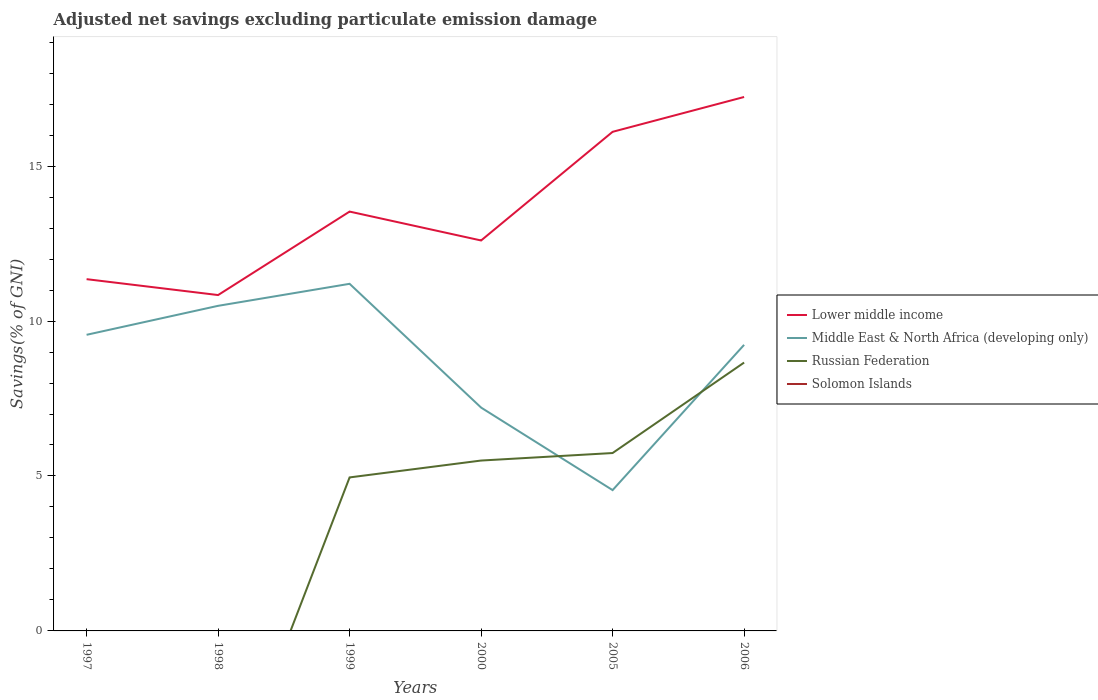Does the line corresponding to Russian Federation intersect with the line corresponding to Middle East & North Africa (developing only)?
Your answer should be compact. Yes. Is the number of lines equal to the number of legend labels?
Your answer should be compact. No. Across all years, what is the maximum adjusted net savings in Russian Federation?
Your response must be concise. 0. What is the total adjusted net savings in Lower middle income in the graph?
Your answer should be very brief. -3.51. What is the difference between the highest and the second highest adjusted net savings in Russian Federation?
Your answer should be compact. 8.66. What is the difference between the highest and the lowest adjusted net savings in Russian Federation?
Make the answer very short. 4. How many years are there in the graph?
Provide a succinct answer. 6. Does the graph contain any zero values?
Give a very brief answer. Yes. Where does the legend appear in the graph?
Give a very brief answer. Center right. How many legend labels are there?
Your answer should be compact. 4. What is the title of the graph?
Make the answer very short. Adjusted net savings excluding particulate emission damage. What is the label or title of the Y-axis?
Your response must be concise. Savings(% of GNI). What is the Savings(% of GNI) of Lower middle income in 1997?
Offer a terse response. 11.35. What is the Savings(% of GNI) in Middle East & North Africa (developing only) in 1997?
Provide a succinct answer. 9.56. What is the Savings(% of GNI) of Russian Federation in 1997?
Keep it short and to the point. 0. What is the Savings(% of GNI) of Solomon Islands in 1997?
Keep it short and to the point. 0. What is the Savings(% of GNI) of Lower middle income in 1998?
Your answer should be compact. 10.84. What is the Savings(% of GNI) of Middle East & North Africa (developing only) in 1998?
Make the answer very short. 10.49. What is the Savings(% of GNI) of Russian Federation in 1998?
Offer a very short reply. 0. What is the Savings(% of GNI) in Solomon Islands in 1998?
Give a very brief answer. 0. What is the Savings(% of GNI) of Lower middle income in 1999?
Your answer should be compact. 13.53. What is the Savings(% of GNI) of Middle East & North Africa (developing only) in 1999?
Offer a terse response. 11.2. What is the Savings(% of GNI) of Russian Federation in 1999?
Your answer should be very brief. 4.95. What is the Savings(% of GNI) in Solomon Islands in 1999?
Provide a short and direct response. 0. What is the Savings(% of GNI) of Lower middle income in 2000?
Provide a short and direct response. 12.6. What is the Savings(% of GNI) in Middle East & North Africa (developing only) in 2000?
Offer a terse response. 7.21. What is the Savings(% of GNI) of Russian Federation in 2000?
Offer a very short reply. 5.5. What is the Savings(% of GNI) of Solomon Islands in 2000?
Your answer should be compact. 0. What is the Savings(% of GNI) of Lower middle income in 2005?
Your answer should be compact. 16.11. What is the Savings(% of GNI) in Middle East & North Africa (developing only) in 2005?
Offer a terse response. 4.54. What is the Savings(% of GNI) of Russian Federation in 2005?
Give a very brief answer. 5.74. What is the Savings(% of GNI) of Solomon Islands in 2005?
Provide a short and direct response. 0. What is the Savings(% of GNI) in Lower middle income in 2006?
Ensure brevity in your answer.  17.23. What is the Savings(% of GNI) in Middle East & North Africa (developing only) in 2006?
Offer a very short reply. 9.23. What is the Savings(% of GNI) in Russian Federation in 2006?
Make the answer very short. 8.66. What is the Savings(% of GNI) in Solomon Islands in 2006?
Your answer should be compact. 0. Across all years, what is the maximum Savings(% of GNI) in Lower middle income?
Offer a very short reply. 17.23. Across all years, what is the maximum Savings(% of GNI) of Middle East & North Africa (developing only)?
Provide a succinct answer. 11.2. Across all years, what is the maximum Savings(% of GNI) of Russian Federation?
Provide a succinct answer. 8.66. Across all years, what is the minimum Savings(% of GNI) of Lower middle income?
Offer a very short reply. 10.84. Across all years, what is the minimum Savings(% of GNI) of Middle East & North Africa (developing only)?
Your response must be concise. 4.54. Across all years, what is the minimum Savings(% of GNI) in Russian Federation?
Provide a succinct answer. 0. What is the total Savings(% of GNI) in Lower middle income in the graph?
Your response must be concise. 81.66. What is the total Savings(% of GNI) of Middle East & North Africa (developing only) in the graph?
Ensure brevity in your answer.  52.23. What is the total Savings(% of GNI) in Russian Federation in the graph?
Offer a terse response. 24.85. What is the difference between the Savings(% of GNI) of Lower middle income in 1997 and that in 1998?
Your answer should be very brief. 0.51. What is the difference between the Savings(% of GNI) in Middle East & North Africa (developing only) in 1997 and that in 1998?
Make the answer very short. -0.93. What is the difference between the Savings(% of GNI) of Lower middle income in 1997 and that in 1999?
Your answer should be compact. -2.18. What is the difference between the Savings(% of GNI) of Middle East & North Africa (developing only) in 1997 and that in 1999?
Your response must be concise. -1.65. What is the difference between the Savings(% of GNI) of Lower middle income in 1997 and that in 2000?
Ensure brevity in your answer.  -1.25. What is the difference between the Savings(% of GNI) of Middle East & North Africa (developing only) in 1997 and that in 2000?
Provide a short and direct response. 2.35. What is the difference between the Savings(% of GNI) in Lower middle income in 1997 and that in 2005?
Give a very brief answer. -4.75. What is the difference between the Savings(% of GNI) of Middle East & North Africa (developing only) in 1997 and that in 2005?
Offer a terse response. 5.01. What is the difference between the Savings(% of GNI) of Lower middle income in 1997 and that in 2006?
Keep it short and to the point. -5.88. What is the difference between the Savings(% of GNI) in Middle East & North Africa (developing only) in 1997 and that in 2006?
Keep it short and to the point. 0.32. What is the difference between the Savings(% of GNI) in Lower middle income in 1998 and that in 1999?
Ensure brevity in your answer.  -2.69. What is the difference between the Savings(% of GNI) in Middle East & North Africa (developing only) in 1998 and that in 1999?
Offer a very short reply. -0.71. What is the difference between the Savings(% of GNI) in Lower middle income in 1998 and that in 2000?
Keep it short and to the point. -1.76. What is the difference between the Savings(% of GNI) of Middle East & North Africa (developing only) in 1998 and that in 2000?
Give a very brief answer. 3.28. What is the difference between the Savings(% of GNI) of Lower middle income in 1998 and that in 2005?
Your answer should be compact. -5.27. What is the difference between the Savings(% of GNI) of Middle East & North Africa (developing only) in 1998 and that in 2005?
Provide a short and direct response. 5.95. What is the difference between the Savings(% of GNI) of Lower middle income in 1998 and that in 2006?
Ensure brevity in your answer.  -6.39. What is the difference between the Savings(% of GNI) of Middle East & North Africa (developing only) in 1998 and that in 2006?
Make the answer very short. 1.26. What is the difference between the Savings(% of GNI) of Lower middle income in 1999 and that in 2000?
Your answer should be compact. 0.93. What is the difference between the Savings(% of GNI) of Middle East & North Africa (developing only) in 1999 and that in 2000?
Give a very brief answer. 3.99. What is the difference between the Savings(% of GNI) in Russian Federation in 1999 and that in 2000?
Your answer should be compact. -0.54. What is the difference between the Savings(% of GNI) in Lower middle income in 1999 and that in 2005?
Offer a terse response. -2.57. What is the difference between the Savings(% of GNI) in Middle East & North Africa (developing only) in 1999 and that in 2005?
Your response must be concise. 6.66. What is the difference between the Savings(% of GNI) in Russian Federation in 1999 and that in 2005?
Offer a terse response. -0.79. What is the difference between the Savings(% of GNI) in Lower middle income in 1999 and that in 2006?
Your answer should be very brief. -3.7. What is the difference between the Savings(% of GNI) of Middle East & North Africa (developing only) in 1999 and that in 2006?
Your answer should be compact. 1.97. What is the difference between the Savings(% of GNI) in Russian Federation in 1999 and that in 2006?
Provide a short and direct response. -3.71. What is the difference between the Savings(% of GNI) of Lower middle income in 2000 and that in 2005?
Your answer should be very brief. -3.51. What is the difference between the Savings(% of GNI) in Middle East & North Africa (developing only) in 2000 and that in 2005?
Offer a terse response. 2.66. What is the difference between the Savings(% of GNI) of Russian Federation in 2000 and that in 2005?
Your answer should be very brief. -0.24. What is the difference between the Savings(% of GNI) of Lower middle income in 2000 and that in 2006?
Offer a very short reply. -4.63. What is the difference between the Savings(% of GNI) in Middle East & North Africa (developing only) in 2000 and that in 2006?
Your answer should be compact. -2.02. What is the difference between the Savings(% of GNI) of Russian Federation in 2000 and that in 2006?
Provide a succinct answer. -3.16. What is the difference between the Savings(% of GNI) of Lower middle income in 2005 and that in 2006?
Keep it short and to the point. -1.12. What is the difference between the Savings(% of GNI) of Middle East & North Africa (developing only) in 2005 and that in 2006?
Give a very brief answer. -4.69. What is the difference between the Savings(% of GNI) of Russian Federation in 2005 and that in 2006?
Provide a short and direct response. -2.92. What is the difference between the Savings(% of GNI) in Lower middle income in 1997 and the Savings(% of GNI) in Middle East & North Africa (developing only) in 1998?
Your answer should be compact. 0.86. What is the difference between the Savings(% of GNI) of Lower middle income in 1997 and the Savings(% of GNI) of Middle East & North Africa (developing only) in 1999?
Offer a terse response. 0.15. What is the difference between the Savings(% of GNI) of Lower middle income in 1997 and the Savings(% of GNI) of Russian Federation in 1999?
Ensure brevity in your answer.  6.4. What is the difference between the Savings(% of GNI) of Middle East & North Africa (developing only) in 1997 and the Savings(% of GNI) of Russian Federation in 1999?
Keep it short and to the point. 4.6. What is the difference between the Savings(% of GNI) in Lower middle income in 1997 and the Savings(% of GNI) in Middle East & North Africa (developing only) in 2000?
Your answer should be very brief. 4.14. What is the difference between the Savings(% of GNI) of Lower middle income in 1997 and the Savings(% of GNI) of Russian Federation in 2000?
Make the answer very short. 5.85. What is the difference between the Savings(% of GNI) in Middle East & North Africa (developing only) in 1997 and the Savings(% of GNI) in Russian Federation in 2000?
Offer a very short reply. 4.06. What is the difference between the Savings(% of GNI) of Lower middle income in 1997 and the Savings(% of GNI) of Middle East & North Africa (developing only) in 2005?
Provide a succinct answer. 6.81. What is the difference between the Savings(% of GNI) of Lower middle income in 1997 and the Savings(% of GNI) of Russian Federation in 2005?
Provide a succinct answer. 5.61. What is the difference between the Savings(% of GNI) of Middle East & North Africa (developing only) in 1997 and the Savings(% of GNI) of Russian Federation in 2005?
Ensure brevity in your answer.  3.82. What is the difference between the Savings(% of GNI) in Lower middle income in 1997 and the Savings(% of GNI) in Middle East & North Africa (developing only) in 2006?
Provide a short and direct response. 2.12. What is the difference between the Savings(% of GNI) in Lower middle income in 1997 and the Savings(% of GNI) in Russian Federation in 2006?
Provide a succinct answer. 2.69. What is the difference between the Savings(% of GNI) in Middle East & North Africa (developing only) in 1997 and the Savings(% of GNI) in Russian Federation in 2006?
Keep it short and to the point. 0.9. What is the difference between the Savings(% of GNI) in Lower middle income in 1998 and the Savings(% of GNI) in Middle East & North Africa (developing only) in 1999?
Offer a very short reply. -0.36. What is the difference between the Savings(% of GNI) in Lower middle income in 1998 and the Savings(% of GNI) in Russian Federation in 1999?
Your answer should be very brief. 5.89. What is the difference between the Savings(% of GNI) of Middle East & North Africa (developing only) in 1998 and the Savings(% of GNI) of Russian Federation in 1999?
Your answer should be compact. 5.54. What is the difference between the Savings(% of GNI) in Lower middle income in 1998 and the Savings(% of GNI) in Middle East & North Africa (developing only) in 2000?
Your answer should be very brief. 3.63. What is the difference between the Savings(% of GNI) in Lower middle income in 1998 and the Savings(% of GNI) in Russian Federation in 2000?
Ensure brevity in your answer.  5.34. What is the difference between the Savings(% of GNI) of Middle East & North Africa (developing only) in 1998 and the Savings(% of GNI) of Russian Federation in 2000?
Make the answer very short. 4.99. What is the difference between the Savings(% of GNI) in Lower middle income in 1998 and the Savings(% of GNI) in Middle East & North Africa (developing only) in 2005?
Your answer should be very brief. 6.29. What is the difference between the Savings(% of GNI) of Lower middle income in 1998 and the Savings(% of GNI) of Russian Federation in 2005?
Make the answer very short. 5.1. What is the difference between the Savings(% of GNI) of Middle East & North Africa (developing only) in 1998 and the Savings(% of GNI) of Russian Federation in 2005?
Offer a terse response. 4.75. What is the difference between the Savings(% of GNI) in Lower middle income in 1998 and the Savings(% of GNI) in Middle East & North Africa (developing only) in 2006?
Your answer should be compact. 1.61. What is the difference between the Savings(% of GNI) in Lower middle income in 1998 and the Savings(% of GNI) in Russian Federation in 2006?
Ensure brevity in your answer.  2.18. What is the difference between the Savings(% of GNI) of Middle East & North Africa (developing only) in 1998 and the Savings(% of GNI) of Russian Federation in 2006?
Keep it short and to the point. 1.83. What is the difference between the Savings(% of GNI) in Lower middle income in 1999 and the Savings(% of GNI) in Middle East & North Africa (developing only) in 2000?
Your answer should be compact. 6.33. What is the difference between the Savings(% of GNI) of Lower middle income in 1999 and the Savings(% of GNI) of Russian Federation in 2000?
Your response must be concise. 8.03. What is the difference between the Savings(% of GNI) of Middle East & North Africa (developing only) in 1999 and the Savings(% of GNI) of Russian Federation in 2000?
Make the answer very short. 5.7. What is the difference between the Savings(% of GNI) in Lower middle income in 1999 and the Savings(% of GNI) in Middle East & North Africa (developing only) in 2005?
Make the answer very short. 8.99. What is the difference between the Savings(% of GNI) of Lower middle income in 1999 and the Savings(% of GNI) of Russian Federation in 2005?
Offer a terse response. 7.79. What is the difference between the Savings(% of GNI) in Middle East & North Africa (developing only) in 1999 and the Savings(% of GNI) in Russian Federation in 2005?
Your answer should be compact. 5.46. What is the difference between the Savings(% of GNI) in Lower middle income in 1999 and the Savings(% of GNI) in Middle East & North Africa (developing only) in 2006?
Keep it short and to the point. 4.3. What is the difference between the Savings(% of GNI) in Lower middle income in 1999 and the Savings(% of GNI) in Russian Federation in 2006?
Your answer should be compact. 4.87. What is the difference between the Savings(% of GNI) in Middle East & North Africa (developing only) in 1999 and the Savings(% of GNI) in Russian Federation in 2006?
Offer a very short reply. 2.54. What is the difference between the Savings(% of GNI) of Lower middle income in 2000 and the Savings(% of GNI) of Middle East & North Africa (developing only) in 2005?
Provide a succinct answer. 8.06. What is the difference between the Savings(% of GNI) of Lower middle income in 2000 and the Savings(% of GNI) of Russian Federation in 2005?
Make the answer very short. 6.86. What is the difference between the Savings(% of GNI) in Middle East & North Africa (developing only) in 2000 and the Savings(% of GNI) in Russian Federation in 2005?
Ensure brevity in your answer.  1.47. What is the difference between the Savings(% of GNI) in Lower middle income in 2000 and the Savings(% of GNI) in Middle East & North Africa (developing only) in 2006?
Offer a very short reply. 3.37. What is the difference between the Savings(% of GNI) in Lower middle income in 2000 and the Savings(% of GNI) in Russian Federation in 2006?
Offer a terse response. 3.94. What is the difference between the Savings(% of GNI) of Middle East & North Africa (developing only) in 2000 and the Savings(% of GNI) of Russian Federation in 2006?
Offer a very short reply. -1.45. What is the difference between the Savings(% of GNI) in Lower middle income in 2005 and the Savings(% of GNI) in Middle East & North Africa (developing only) in 2006?
Make the answer very short. 6.87. What is the difference between the Savings(% of GNI) in Lower middle income in 2005 and the Savings(% of GNI) in Russian Federation in 2006?
Your answer should be compact. 7.45. What is the difference between the Savings(% of GNI) of Middle East & North Africa (developing only) in 2005 and the Savings(% of GNI) of Russian Federation in 2006?
Provide a succinct answer. -4.12. What is the average Savings(% of GNI) in Lower middle income per year?
Keep it short and to the point. 13.61. What is the average Savings(% of GNI) in Middle East & North Africa (developing only) per year?
Your answer should be compact. 8.71. What is the average Savings(% of GNI) of Russian Federation per year?
Keep it short and to the point. 4.14. In the year 1997, what is the difference between the Savings(% of GNI) in Lower middle income and Savings(% of GNI) in Middle East & North Africa (developing only)?
Give a very brief answer. 1.8. In the year 1998, what is the difference between the Savings(% of GNI) of Lower middle income and Savings(% of GNI) of Middle East & North Africa (developing only)?
Offer a very short reply. 0.35. In the year 1999, what is the difference between the Savings(% of GNI) in Lower middle income and Savings(% of GNI) in Middle East & North Africa (developing only)?
Make the answer very short. 2.33. In the year 1999, what is the difference between the Savings(% of GNI) of Lower middle income and Savings(% of GNI) of Russian Federation?
Provide a short and direct response. 8.58. In the year 1999, what is the difference between the Savings(% of GNI) of Middle East & North Africa (developing only) and Savings(% of GNI) of Russian Federation?
Your response must be concise. 6.25. In the year 2000, what is the difference between the Savings(% of GNI) of Lower middle income and Savings(% of GNI) of Middle East & North Africa (developing only)?
Your answer should be very brief. 5.39. In the year 2000, what is the difference between the Savings(% of GNI) in Lower middle income and Savings(% of GNI) in Russian Federation?
Make the answer very short. 7.1. In the year 2000, what is the difference between the Savings(% of GNI) in Middle East & North Africa (developing only) and Savings(% of GNI) in Russian Federation?
Your answer should be compact. 1.71. In the year 2005, what is the difference between the Savings(% of GNI) in Lower middle income and Savings(% of GNI) in Middle East & North Africa (developing only)?
Give a very brief answer. 11.56. In the year 2005, what is the difference between the Savings(% of GNI) of Lower middle income and Savings(% of GNI) of Russian Federation?
Give a very brief answer. 10.37. In the year 2005, what is the difference between the Savings(% of GNI) of Middle East & North Africa (developing only) and Savings(% of GNI) of Russian Federation?
Your answer should be very brief. -1.2. In the year 2006, what is the difference between the Savings(% of GNI) of Lower middle income and Savings(% of GNI) of Middle East & North Africa (developing only)?
Offer a very short reply. 8. In the year 2006, what is the difference between the Savings(% of GNI) in Lower middle income and Savings(% of GNI) in Russian Federation?
Give a very brief answer. 8.57. In the year 2006, what is the difference between the Savings(% of GNI) in Middle East & North Africa (developing only) and Savings(% of GNI) in Russian Federation?
Your answer should be compact. 0.57. What is the ratio of the Savings(% of GNI) in Lower middle income in 1997 to that in 1998?
Your response must be concise. 1.05. What is the ratio of the Savings(% of GNI) in Middle East & North Africa (developing only) in 1997 to that in 1998?
Make the answer very short. 0.91. What is the ratio of the Savings(% of GNI) in Lower middle income in 1997 to that in 1999?
Your answer should be very brief. 0.84. What is the ratio of the Savings(% of GNI) in Middle East & North Africa (developing only) in 1997 to that in 1999?
Ensure brevity in your answer.  0.85. What is the ratio of the Savings(% of GNI) in Lower middle income in 1997 to that in 2000?
Provide a succinct answer. 0.9. What is the ratio of the Savings(% of GNI) in Middle East & North Africa (developing only) in 1997 to that in 2000?
Provide a short and direct response. 1.33. What is the ratio of the Savings(% of GNI) in Lower middle income in 1997 to that in 2005?
Provide a succinct answer. 0.7. What is the ratio of the Savings(% of GNI) of Middle East & North Africa (developing only) in 1997 to that in 2005?
Keep it short and to the point. 2.1. What is the ratio of the Savings(% of GNI) in Lower middle income in 1997 to that in 2006?
Your answer should be compact. 0.66. What is the ratio of the Savings(% of GNI) of Middle East & North Africa (developing only) in 1997 to that in 2006?
Make the answer very short. 1.04. What is the ratio of the Savings(% of GNI) of Lower middle income in 1998 to that in 1999?
Offer a terse response. 0.8. What is the ratio of the Savings(% of GNI) of Middle East & North Africa (developing only) in 1998 to that in 1999?
Offer a terse response. 0.94. What is the ratio of the Savings(% of GNI) in Lower middle income in 1998 to that in 2000?
Offer a very short reply. 0.86. What is the ratio of the Savings(% of GNI) in Middle East & North Africa (developing only) in 1998 to that in 2000?
Your response must be concise. 1.46. What is the ratio of the Savings(% of GNI) of Lower middle income in 1998 to that in 2005?
Ensure brevity in your answer.  0.67. What is the ratio of the Savings(% of GNI) in Middle East & North Africa (developing only) in 1998 to that in 2005?
Your answer should be very brief. 2.31. What is the ratio of the Savings(% of GNI) in Lower middle income in 1998 to that in 2006?
Your response must be concise. 0.63. What is the ratio of the Savings(% of GNI) in Middle East & North Africa (developing only) in 1998 to that in 2006?
Ensure brevity in your answer.  1.14. What is the ratio of the Savings(% of GNI) of Lower middle income in 1999 to that in 2000?
Your response must be concise. 1.07. What is the ratio of the Savings(% of GNI) of Middle East & North Africa (developing only) in 1999 to that in 2000?
Your answer should be compact. 1.55. What is the ratio of the Savings(% of GNI) of Russian Federation in 1999 to that in 2000?
Provide a succinct answer. 0.9. What is the ratio of the Savings(% of GNI) of Lower middle income in 1999 to that in 2005?
Your response must be concise. 0.84. What is the ratio of the Savings(% of GNI) in Middle East & North Africa (developing only) in 1999 to that in 2005?
Provide a succinct answer. 2.47. What is the ratio of the Savings(% of GNI) of Russian Federation in 1999 to that in 2005?
Offer a terse response. 0.86. What is the ratio of the Savings(% of GNI) in Lower middle income in 1999 to that in 2006?
Give a very brief answer. 0.79. What is the ratio of the Savings(% of GNI) of Middle East & North Africa (developing only) in 1999 to that in 2006?
Your response must be concise. 1.21. What is the ratio of the Savings(% of GNI) of Russian Federation in 1999 to that in 2006?
Offer a terse response. 0.57. What is the ratio of the Savings(% of GNI) of Lower middle income in 2000 to that in 2005?
Offer a very short reply. 0.78. What is the ratio of the Savings(% of GNI) of Middle East & North Africa (developing only) in 2000 to that in 2005?
Provide a short and direct response. 1.59. What is the ratio of the Savings(% of GNI) in Russian Federation in 2000 to that in 2005?
Offer a terse response. 0.96. What is the ratio of the Savings(% of GNI) of Lower middle income in 2000 to that in 2006?
Your answer should be very brief. 0.73. What is the ratio of the Savings(% of GNI) in Middle East & North Africa (developing only) in 2000 to that in 2006?
Offer a terse response. 0.78. What is the ratio of the Savings(% of GNI) in Russian Federation in 2000 to that in 2006?
Offer a very short reply. 0.63. What is the ratio of the Savings(% of GNI) of Lower middle income in 2005 to that in 2006?
Your answer should be compact. 0.93. What is the ratio of the Savings(% of GNI) of Middle East & North Africa (developing only) in 2005 to that in 2006?
Provide a succinct answer. 0.49. What is the ratio of the Savings(% of GNI) in Russian Federation in 2005 to that in 2006?
Give a very brief answer. 0.66. What is the difference between the highest and the second highest Savings(% of GNI) in Lower middle income?
Provide a short and direct response. 1.12. What is the difference between the highest and the second highest Savings(% of GNI) of Middle East & North Africa (developing only)?
Your answer should be very brief. 0.71. What is the difference between the highest and the second highest Savings(% of GNI) of Russian Federation?
Keep it short and to the point. 2.92. What is the difference between the highest and the lowest Savings(% of GNI) of Lower middle income?
Your answer should be compact. 6.39. What is the difference between the highest and the lowest Savings(% of GNI) of Middle East & North Africa (developing only)?
Give a very brief answer. 6.66. What is the difference between the highest and the lowest Savings(% of GNI) of Russian Federation?
Your response must be concise. 8.66. 